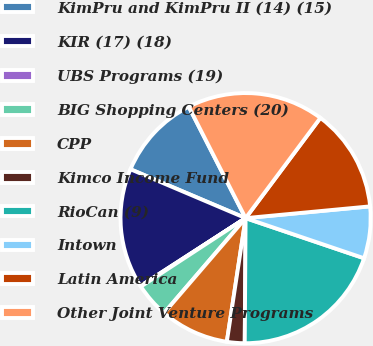Convert chart. <chart><loc_0><loc_0><loc_500><loc_500><pie_chart><fcel>KimPru and KimPru II (14) (15)<fcel>KIR (17) (18)<fcel>UBS Programs (19)<fcel>BIG Shopping Centers (20)<fcel>CPP<fcel>Kimco Income Fund<fcel>RioCan (9)<fcel>Intown<fcel>Latin America<fcel>Other Joint Venture Programs<nl><fcel>11.1%<fcel>15.51%<fcel>0.09%<fcel>4.49%<fcel>8.9%<fcel>2.29%<fcel>19.91%<fcel>6.7%<fcel>13.3%<fcel>17.71%<nl></chart> 